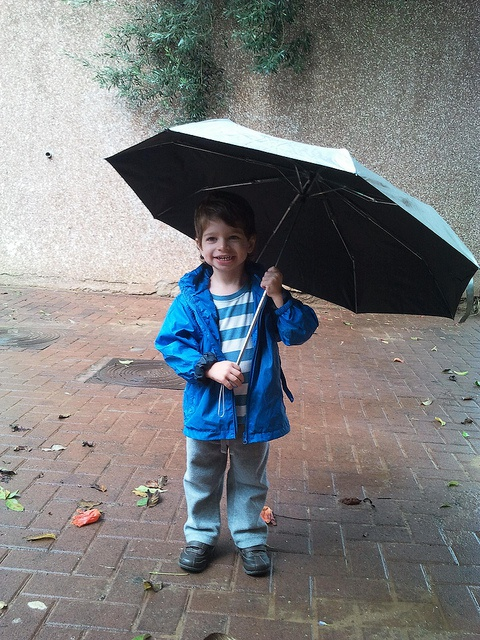Describe the objects in this image and their specific colors. I can see umbrella in lightgray, black, white, lightblue, and darkgray tones and people in lightgray, black, navy, gray, and blue tones in this image. 